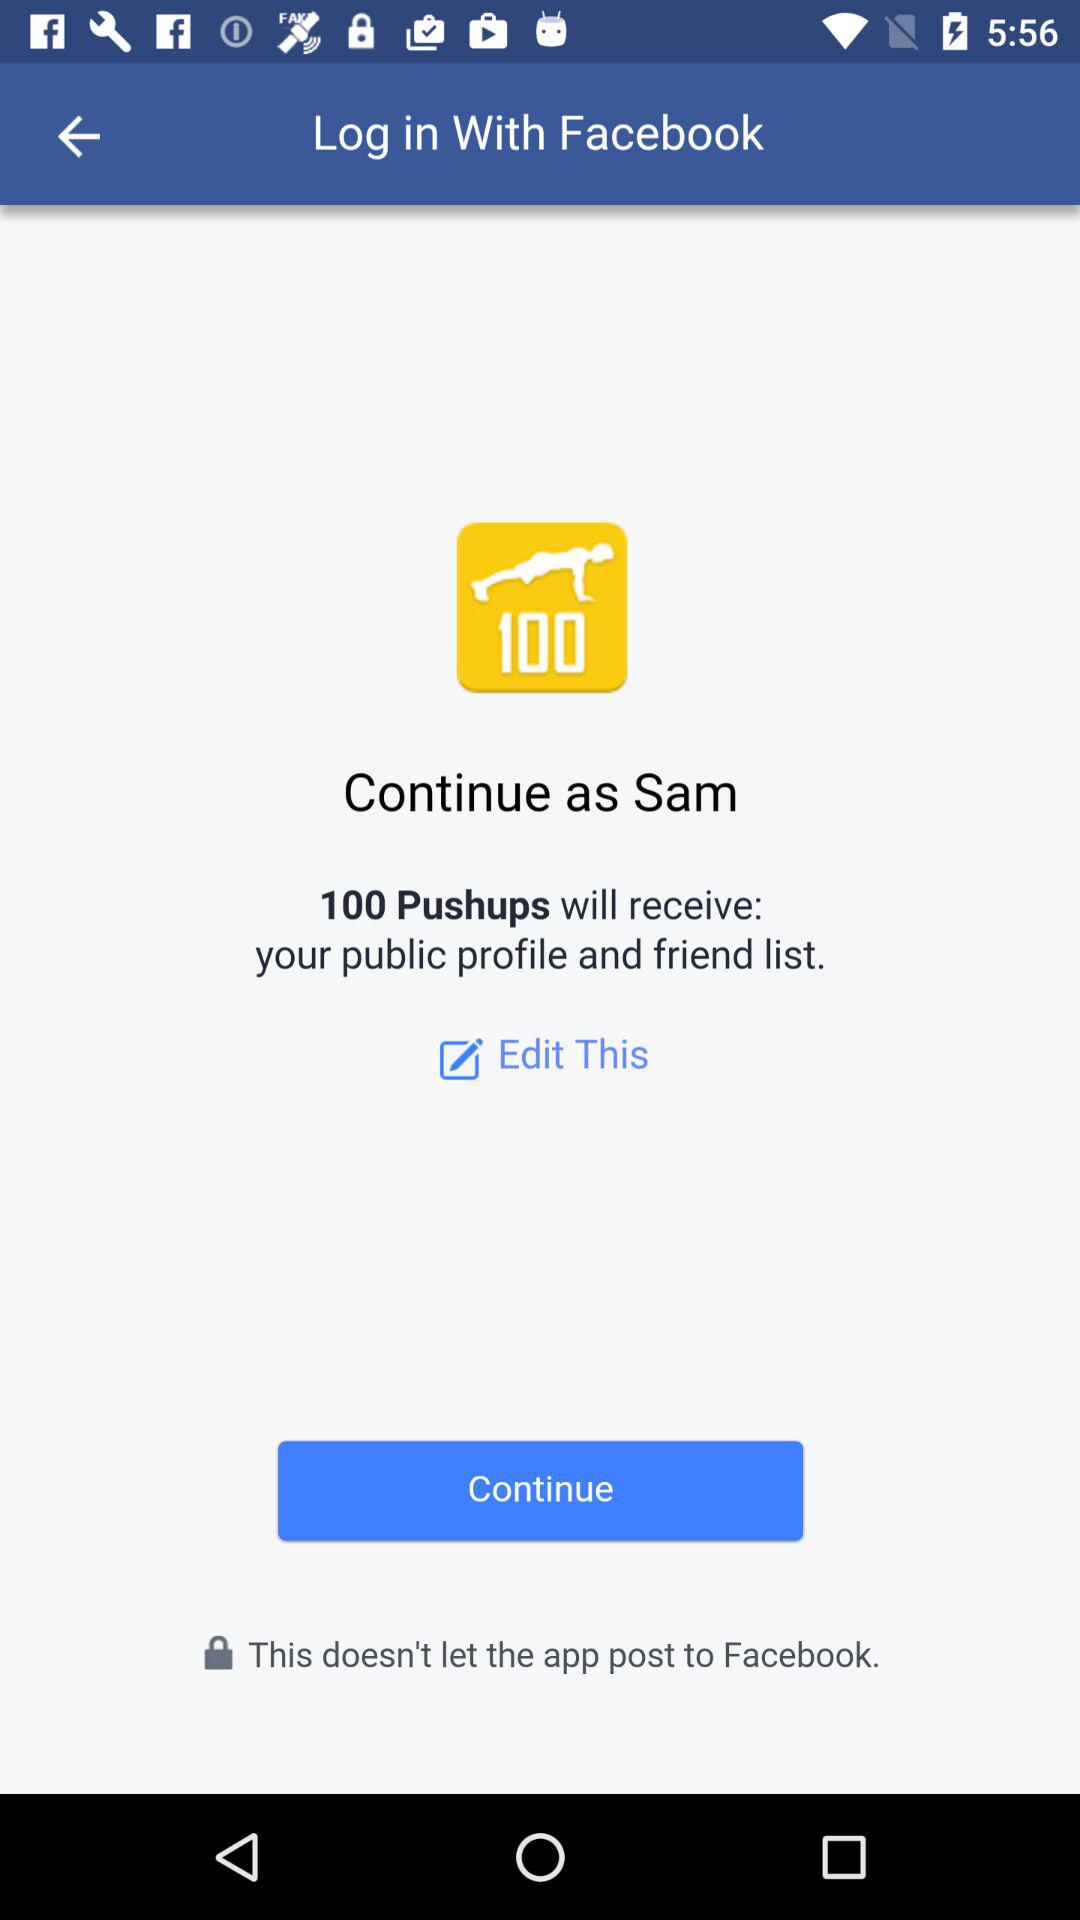How many different ways can I continue?
Answer the question using a single word or phrase. 2 